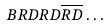<formula> <loc_0><loc_0><loc_500><loc_500>B R D R D \overline { R D } \dots</formula> 